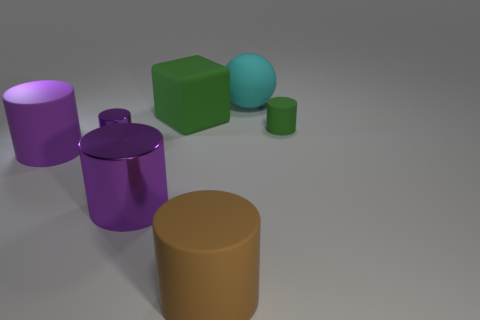Is the color of the large metal thing the same as the rubber object to the left of the block?
Provide a succinct answer. Yes. What material is the large object that is the same color as the big shiny cylinder?
Give a very brief answer. Rubber. Are there any other things that have the same shape as the cyan thing?
Provide a succinct answer. No. There is a small object on the left side of the rubber cylinder right of the matte thing in front of the purple rubber thing; what shape is it?
Your response must be concise. Cylinder. What is the shape of the big green matte object?
Make the answer very short. Cube. What is the color of the small object that is to the right of the tiny purple cylinder?
Offer a very short reply. Green. There is a cyan ball that is behind the brown matte cylinder; is its size the same as the green matte block?
Keep it short and to the point. Yes. What size is the other brown matte object that is the same shape as the small rubber object?
Offer a very short reply. Large. Is the purple matte object the same shape as the big cyan thing?
Your answer should be compact. No. Are there fewer tiny purple metal cylinders that are on the right side of the purple matte cylinder than rubber objects that are in front of the large matte ball?
Ensure brevity in your answer.  Yes. 